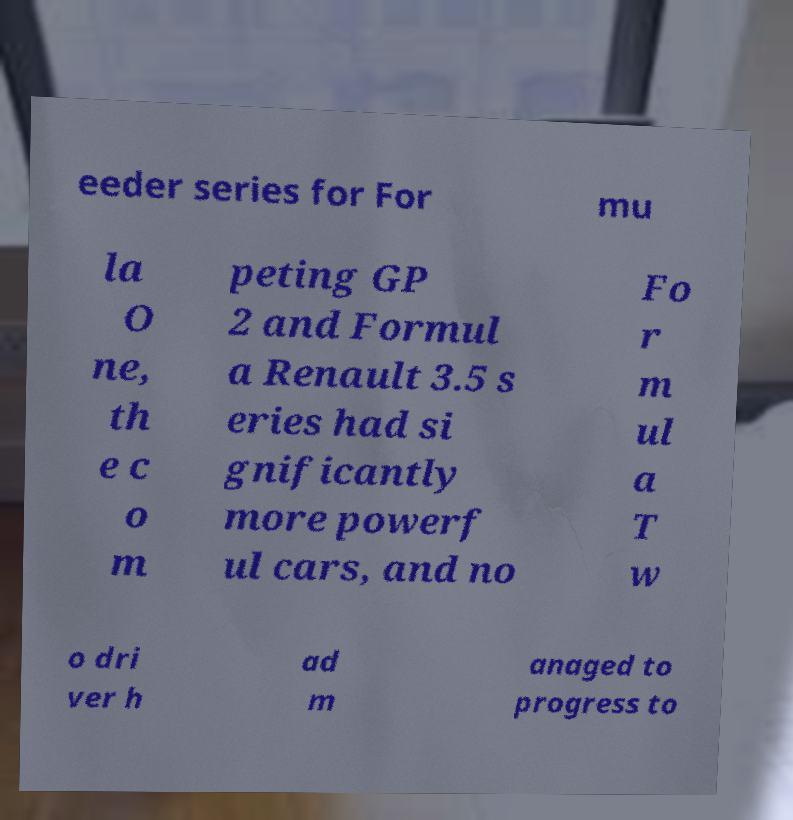Can you accurately transcribe the text from the provided image for me? eeder series for For mu la O ne, th e c o m peting GP 2 and Formul a Renault 3.5 s eries had si gnificantly more powerf ul cars, and no Fo r m ul a T w o dri ver h ad m anaged to progress to 